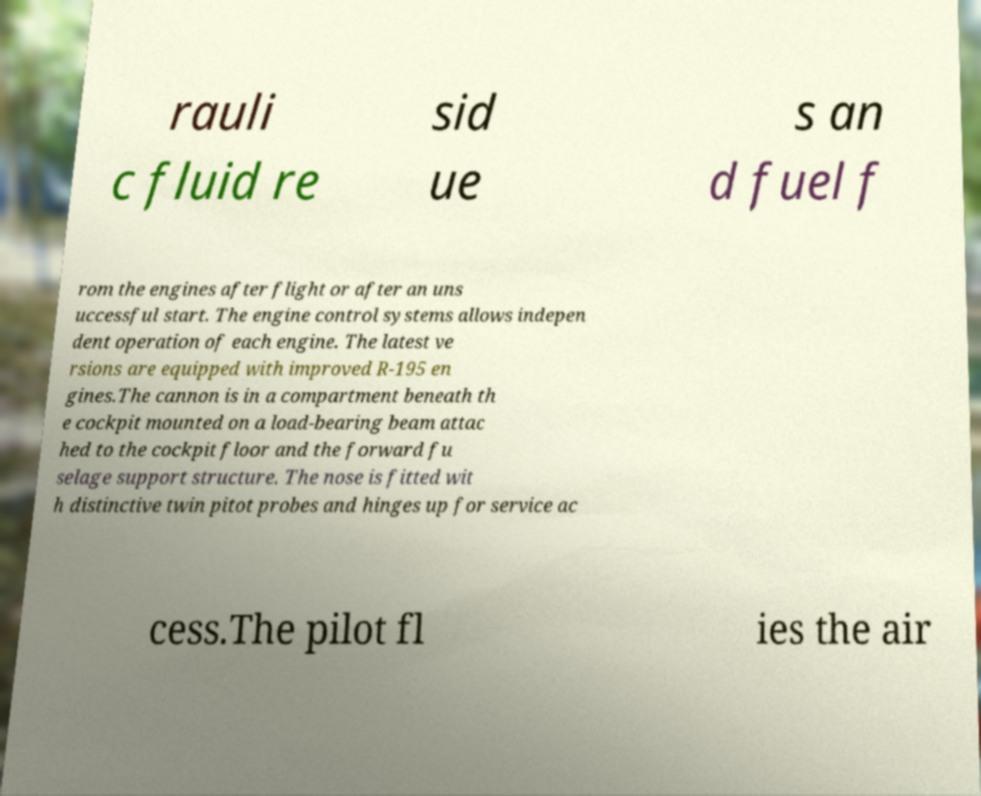Can you accurately transcribe the text from the provided image for me? rauli c fluid re sid ue s an d fuel f rom the engines after flight or after an uns uccessful start. The engine control systems allows indepen dent operation of each engine. The latest ve rsions are equipped with improved R-195 en gines.The cannon is in a compartment beneath th e cockpit mounted on a load-bearing beam attac hed to the cockpit floor and the forward fu selage support structure. The nose is fitted wit h distinctive twin pitot probes and hinges up for service ac cess.The pilot fl ies the air 